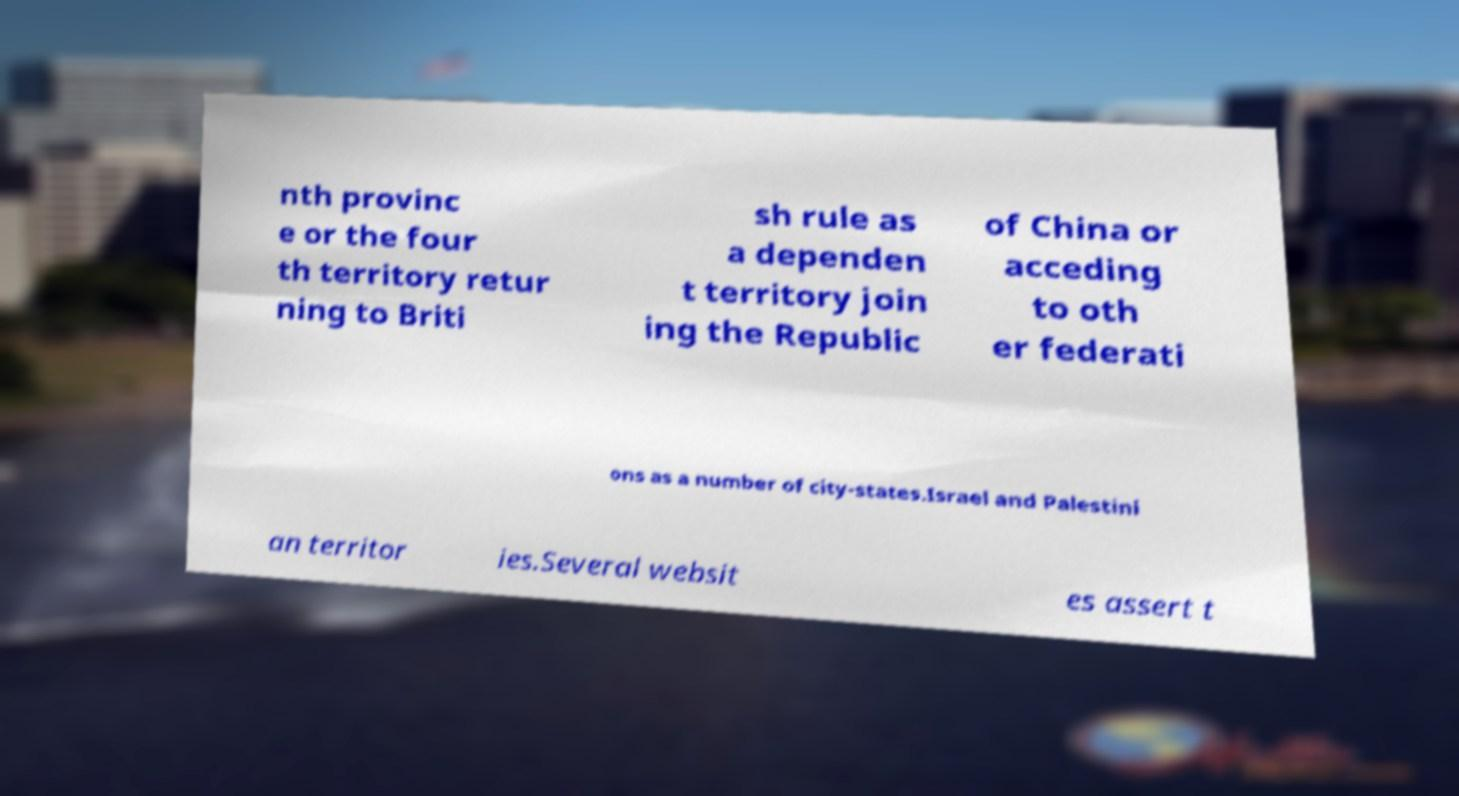What messages or text are displayed in this image? I need them in a readable, typed format. nth provinc e or the four th territory retur ning to Briti sh rule as a dependen t territory join ing the Republic of China or acceding to oth er federati ons as a number of city-states.Israel and Palestini an territor ies.Several websit es assert t 